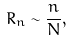<formula> <loc_0><loc_0><loc_500><loc_500>R _ { n } \sim \frac { n } { N } ,</formula> 